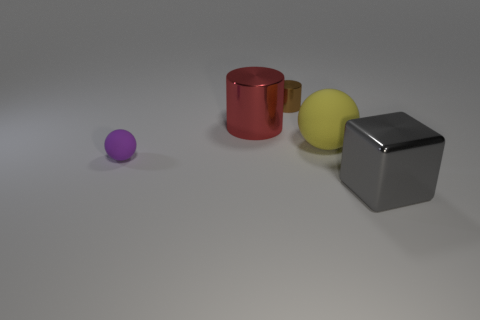Add 4 big matte blocks. How many objects exist? 9 Subtract all cubes. How many objects are left? 4 Subtract all big blocks. Subtract all big gray metallic blocks. How many objects are left? 3 Add 2 brown metal cylinders. How many brown metal cylinders are left? 3 Add 1 red metallic cylinders. How many red metallic cylinders exist? 2 Subtract 1 purple balls. How many objects are left? 4 